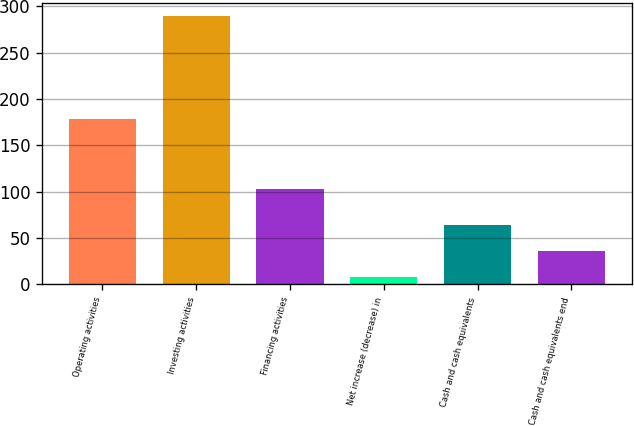Convert chart to OTSL. <chart><loc_0><loc_0><loc_500><loc_500><bar_chart><fcel>Operating activities<fcel>Investing activities<fcel>Financing activities<fcel>Net increase (decrease) in<fcel>Cash and cash equivalents<fcel>Cash and cash equivalents end<nl><fcel>178.8<fcel>289.5<fcel>103.2<fcel>7.5<fcel>63.9<fcel>35.7<nl></chart> 